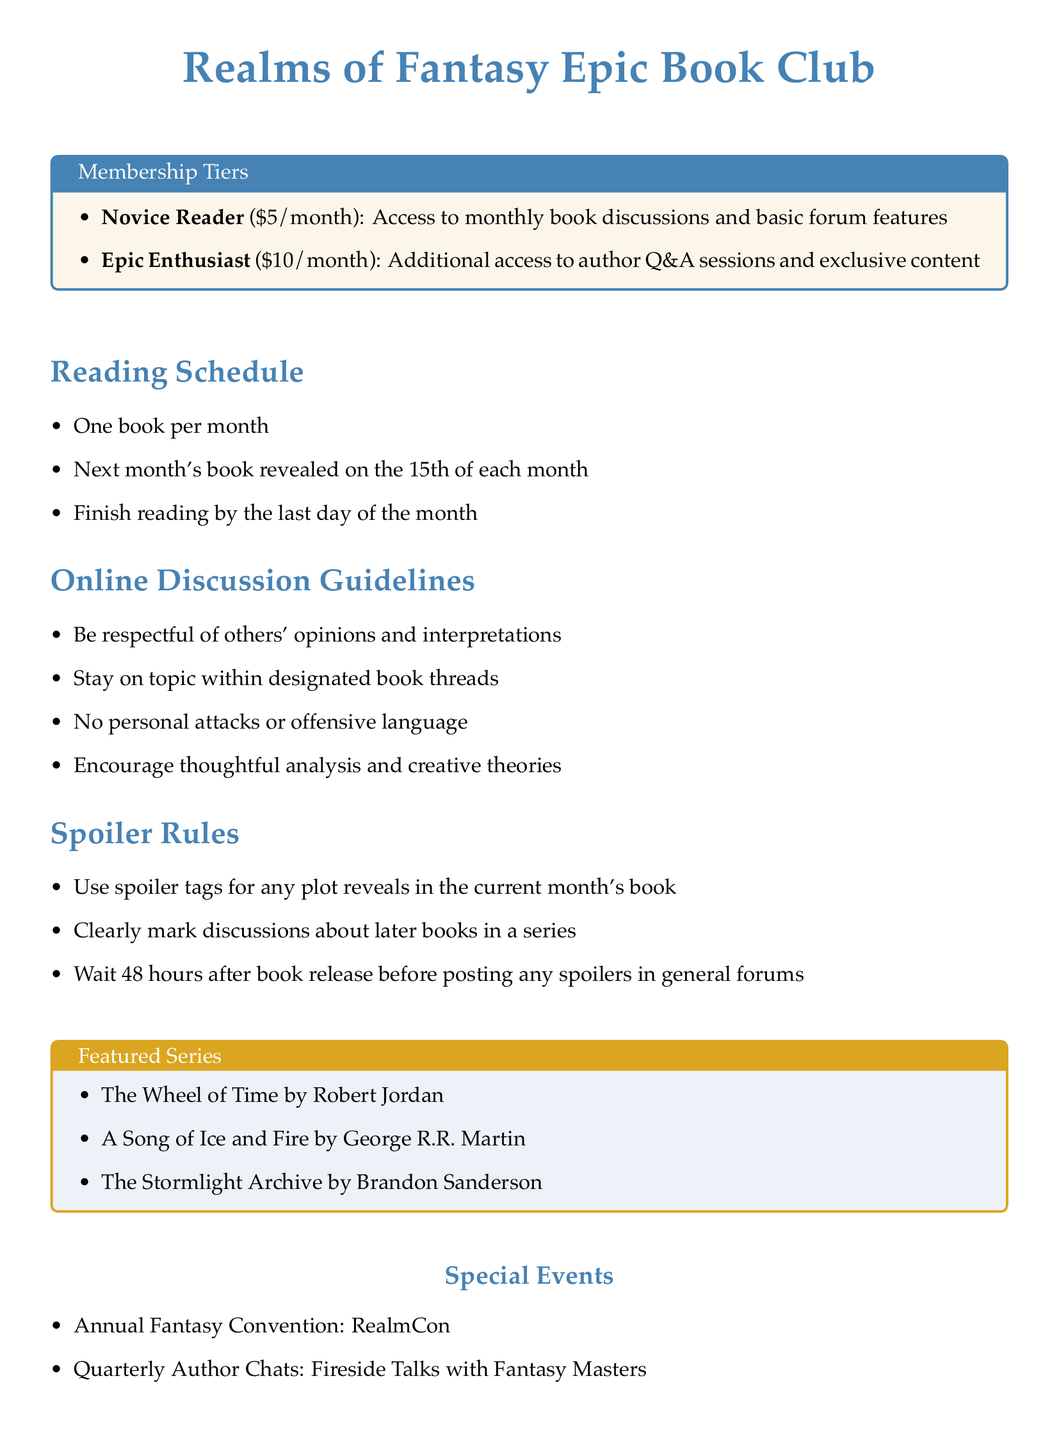What are the two membership tiers? The membership tiers listed in the document are Novice Reader and Epic Enthusiast.
Answer: Novice Reader, Epic Enthusiast How much does the Epic Enthusiast tier cost? The document specifies that the Epic Enthusiast membership costs $10/month.
Answer: $10/month When is next month's book revealed? According to the reading schedule, next month's book is revealed on the 15th of each month.
Answer: 15th of each month What should you do with spoilers in the current month's book? The spoiler rules indicate that you should use spoiler tags for any plot reveals in the current month's book.
Answer: Use spoiler tags What event occurs annually according to the document? The document mentions an annual event called RealmCon.
Answer: RealmCon What is encouraged in online discussions? The guidelines state that members should encourage thoughtful analysis and creative theories in discussions.
Answer: Thoughtful analysis and creative theories How many books are read each month? The reading schedule specifies that the book club reads one book per month.
Answer: One book What is the waiting period before discussing spoilers in general forums? The document notes that you must wait 48 hours after book release before posting spoilers in general forums.
Answer: 48 hours 